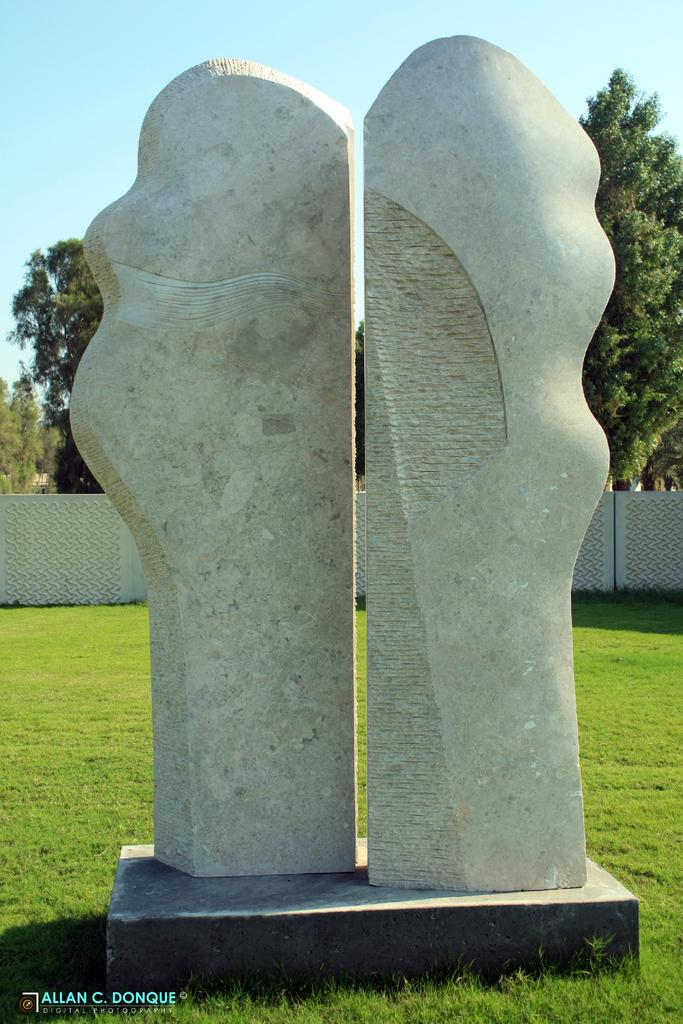How many sculptures can be seen in the image? There are two sculptures in the image. What is the sculptures resting on? The sculptures are on an object. What type of natural environment is visible in the image? There is grass, sky, and trees visible in the image. What type of man-made structures are present in the image? There are walls in the image. Is there any text or marking at the bottom of the image? Yes, there is a watermark at the bottom of the image. What is the desire of the mountain in the image? There is no mountain present in the image, so it is not possible to determine its desires. 